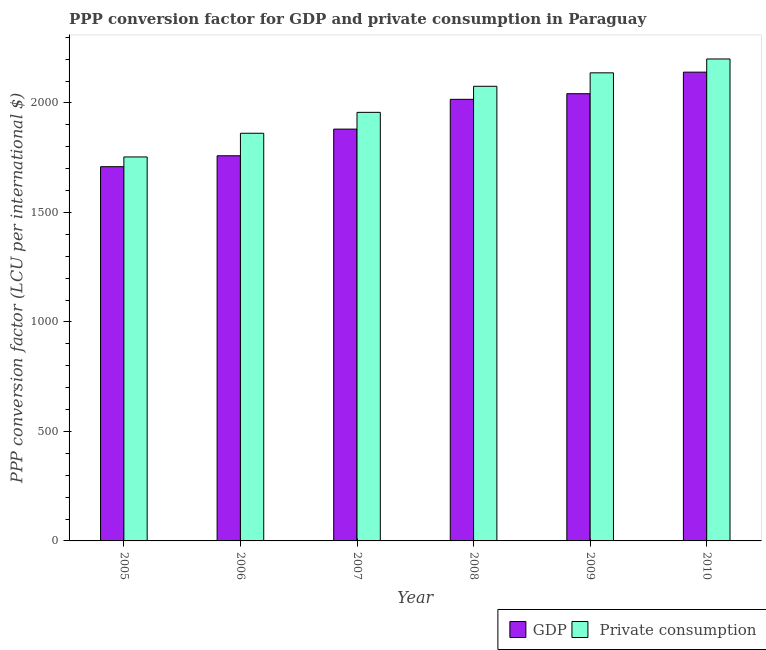Are the number of bars on each tick of the X-axis equal?
Offer a very short reply. Yes. How many bars are there on the 4th tick from the left?
Provide a short and direct response. 2. How many bars are there on the 5th tick from the right?
Your answer should be compact. 2. What is the ppp conversion factor for private consumption in 2007?
Offer a terse response. 1956.94. Across all years, what is the maximum ppp conversion factor for private consumption?
Give a very brief answer. 2200.69. Across all years, what is the minimum ppp conversion factor for private consumption?
Give a very brief answer. 1753.34. What is the total ppp conversion factor for private consumption in the graph?
Make the answer very short. 1.20e+04. What is the difference between the ppp conversion factor for gdp in 2007 and that in 2008?
Provide a succinct answer. -135.99. What is the difference between the ppp conversion factor for gdp in 2008 and the ppp conversion factor for private consumption in 2007?
Your answer should be compact. 135.99. What is the average ppp conversion factor for gdp per year?
Your answer should be compact. 1924.47. In the year 2008, what is the difference between the ppp conversion factor for gdp and ppp conversion factor for private consumption?
Keep it short and to the point. 0. In how many years, is the ppp conversion factor for private consumption greater than 100 LCU?
Provide a succinct answer. 6. What is the ratio of the ppp conversion factor for gdp in 2007 to that in 2009?
Ensure brevity in your answer.  0.92. Is the ppp conversion factor for gdp in 2008 less than that in 2009?
Your answer should be very brief. Yes. What is the difference between the highest and the second highest ppp conversion factor for gdp?
Keep it short and to the point. 98.43. What is the difference between the highest and the lowest ppp conversion factor for private consumption?
Keep it short and to the point. 447.35. Is the sum of the ppp conversion factor for gdp in 2005 and 2008 greater than the maximum ppp conversion factor for private consumption across all years?
Offer a terse response. Yes. What does the 2nd bar from the left in 2010 represents?
Give a very brief answer.  Private consumption. What does the 2nd bar from the right in 2006 represents?
Give a very brief answer. GDP. How many bars are there?
Provide a succinct answer. 12. Are all the bars in the graph horizontal?
Your answer should be very brief. No. Does the graph contain any zero values?
Make the answer very short. No. What is the title of the graph?
Keep it short and to the point. PPP conversion factor for GDP and private consumption in Paraguay. What is the label or title of the Y-axis?
Offer a very short reply. PPP conversion factor (LCU per international $). What is the PPP conversion factor (LCU per international $) of GDP in 2005?
Make the answer very short. 1708.78. What is the PPP conversion factor (LCU per international $) in  Private consumption in 2005?
Give a very brief answer. 1753.34. What is the PPP conversion factor (LCU per international $) of GDP in 2006?
Give a very brief answer. 1758.68. What is the PPP conversion factor (LCU per international $) in  Private consumption in 2006?
Provide a short and direct response. 1861.45. What is the PPP conversion factor (LCU per international $) of GDP in 2007?
Provide a succinct answer. 1880.39. What is the PPP conversion factor (LCU per international $) of  Private consumption in 2007?
Ensure brevity in your answer.  1956.94. What is the PPP conversion factor (LCU per international $) in GDP in 2008?
Ensure brevity in your answer.  2016.39. What is the PPP conversion factor (LCU per international $) in  Private consumption in 2008?
Make the answer very short. 2075.96. What is the PPP conversion factor (LCU per international $) in GDP in 2009?
Provide a short and direct response. 2042.08. What is the PPP conversion factor (LCU per international $) in  Private consumption in 2009?
Provide a short and direct response. 2137.37. What is the PPP conversion factor (LCU per international $) of GDP in 2010?
Provide a short and direct response. 2140.51. What is the PPP conversion factor (LCU per international $) in  Private consumption in 2010?
Ensure brevity in your answer.  2200.69. Across all years, what is the maximum PPP conversion factor (LCU per international $) of GDP?
Provide a short and direct response. 2140.51. Across all years, what is the maximum PPP conversion factor (LCU per international $) of  Private consumption?
Make the answer very short. 2200.69. Across all years, what is the minimum PPP conversion factor (LCU per international $) in GDP?
Give a very brief answer. 1708.78. Across all years, what is the minimum PPP conversion factor (LCU per international $) of  Private consumption?
Your response must be concise. 1753.34. What is the total PPP conversion factor (LCU per international $) of GDP in the graph?
Offer a very short reply. 1.15e+04. What is the total PPP conversion factor (LCU per international $) of  Private consumption in the graph?
Give a very brief answer. 1.20e+04. What is the difference between the PPP conversion factor (LCU per international $) of GDP in 2005 and that in 2006?
Offer a terse response. -49.91. What is the difference between the PPP conversion factor (LCU per international $) in  Private consumption in 2005 and that in 2006?
Offer a terse response. -108.12. What is the difference between the PPP conversion factor (LCU per international $) in GDP in 2005 and that in 2007?
Offer a terse response. -171.62. What is the difference between the PPP conversion factor (LCU per international $) of  Private consumption in 2005 and that in 2007?
Your answer should be compact. -203.61. What is the difference between the PPP conversion factor (LCU per international $) of GDP in 2005 and that in 2008?
Make the answer very short. -307.61. What is the difference between the PPP conversion factor (LCU per international $) in  Private consumption in 2005 and that in 2008?
Ensure brevity in your answer.  -322.63. What is the difference between the PPP conversion factor (LCU per international $) in GDP in 2005 and that in 2009?
Your answer should be very brief. -333.3. What is the difference between the PPP conversion factor (LCU per international $) in  Private consumption in 2005 and that in 2009?
Provide a short and direct response. -384.03. What is the difference between the PPP conversion factor (LCU per international $) in GDP in 2005 and that in 2010?
Give a very brief answer. -431.73. What is the difference between the PPP conversion factor (LCU per international $) of  Private consumption in 2005 and that in 2010?
Offer a terse response. -447.35. What is the difference between the PPP conversion factor (LCU per international $) of GDP in 2006 and that in 2007?
Offer a terse response. -121.71. What is the difference between the PPP conversion factor (LCU per international $) of  Private consumption in 2006 and that in 2007?
Provide a short and direct response. -95.49. What is the difference between the PPP conversion factor (LCU per international $) of GDP in 2006 and that in 2008?
Give a very brief answer. -257.7. What is the difference between the PPP conversion factor (LCU per international $) of  Private consumption in 2006 and that in 2008?
Make the answer very short. -214.51. What is the difference between the PPP conversion factor (LCU per international $) of GDP in 2006 and that in 2009?
Give a very brief answer. -283.39. What is the difference between the PPP conversion factor (LCU per international $) in  Private consumption in 2006 and that in 2009?
Keep it short and to the point. -275.92. What is the difference between the PPP conversion factor (LCU per international $) in GDP in 2006 and that in 2010?
Provide a succinct answer. -381.82. What is the difference between the PPP conversion factor (LCU per international $) of  Private consumption in 2006 and that in 2010?
Your response must be concise. -339.24. What is the difference between the PPP conversion factor (LCU per international $) in GDP in 2007 and that in 2008?
Your answer should be very brief. -135.99. What is the difference between the PPP conversion factor (LCU per international $) in  Private consumption in 2007 and that in 2008?
Your response must be concise. -119.02. What is the difference between the PPP conversion factor (LCU per international $) of GDP in 2007 and that in 2009?
Give a very brief answer. -161.68. What is the difference between the PPP conversion factor (LCU per international $) in  Private consumption in 2007 and that in 2009?
Provide a succinct answer. -180.43. What is the difference between the PPP conversion factor (LCU per international $) of GDP in 2007 and that in 2010?
Give a very brief answer. -260.11. What is the difference between the PPP conversion factor (LCU per international $) in  Private consumption in 2007 and that in 2010?
Offer a very short reply. -243.75. What is the difference between the PPP conversion factor (LCU per international $) in GDP in 2008 and that in 2009?
Offer a very short reply. -25.69. What is the difference between the PPP conversion factor (LCU per international $) of  Private consumption in 2008 and that in 2009?
Provide a succinct answer. -61.41. What is the difference between the PPP conversion factor (LCU per international $) of GDP in 2008 and that in 2010?
Your answer should be very brief. -124.12. What is the difference between the PPP conversion factor (LCU per international $) of  Private consumption in 2008 and that in 2010?
Provide a short and direct response. -124.73. What is the difference between the PPP conversion factor (LCU per international $) of GDP in 2009 and that in 2010?
Keep it short and to the point. -98.43. What is the difference between the PPP conversion factor (LCU per international $) in  Private consumption in 2009 and that in 2010?
Give a very brief answer. -63.32. What is the difference between the PPP conversion factor (LCU per international $) of GDP in 2005 and the PPP conversion factor (LCU per international $) of  Private consumption in 2006?
Your response must be concise. -152.68. What is the difference between the PPP conversion factor (LCU per international $) in GDP in 2005 and the PPP conversion factor (LCU per international $) in  Private consumption in 2007?
Offer a terse response. -248.17. What is the difference between the PPP conversion factor (LCU per international $) in GDP in 2005 and the PPP conversion factor (LCU per international $) in  Private consumption in 2008?
Keep it short and to the point. -367.19. What is the difference between the PPP conversion factor (LCU per international $) of GDP in 2005 and the PPP conversion factor (LCU per international $) of  Private consumption in 2009?
Offer a very short reply. -428.6. What is the difference between the PPP conversion factor (LCU per international $) in GDP in 2005 and the PPP conversion factor (LCU per international $) in  Private consumption in 2010?
Your answer should be very brief. -491.92. What is the difference between the PPP conversion factor (LCU per international $) of GDP in 2006 and the PPP conversion factor (LCU per international $) of  Private consumption in 2007?
Ensure brevity in your answer.  -198.26. What is the difference between the PPP conversion factor (LCU per international $) in GDP in 2006 and the PPP conversion factor (LCU per international $) in  Private consumption in 2008?
Ensure brevity in your answer.  -317.28. What is the difference between the PPP conversion factor (LCU per international $) of GDP in 2006 and the PPP conversion factor (LCU per international $) of  Private consumption in 2009?
Your answer should be compact. -378.69. What is the difference between the PPP conversion factor (LCU per international $) of GDP in 2006 and the PPP conversion factor (LCU per international $) of  Private consumption in 2010?
Offer a very short reply. -442.01. What is the difference between the PPP conversion factor (LCU per international $) in GDP in 2007 and the PPP conversion factor (LCU per international $) in  Private consumption in 2008?
Make the answer very short. -195.57. What is the difference between the PPP conversion factor (LCU per international $) in GDP in 2007 and the PPP conversion factor (LCU per international $) in  Private consumption in 2009?
Make the answer very short. -256.98. What is the difference between the PPP conversion factor (LCU per international $) in GDP in 2007 and the PPP conversion factor (LCU per international $) in  Private consumption in 2010?
Your answer should be compact. -320.3. What is the difference between the PPP conversion factor (LCU per international $) of GDP in 2008 and the PPP conversion factor (LCU per international $) of  Private consumption in 2009?
Give a very brief answer. -120.98. What is the difference between the PPP conversion factor (LCU per international $) in GDP in 2008 and the PPP conversion factor (LCU per international $) in  Private consumption in 2010?
Your response must be concise. -184.3. What is the difference between the PPP conversion factor (LCU per international $) of GDP in 2009 and the PPP conversion factor (LCU per international $) of  Private consumption in 2010?
Provide a short and direct response. -158.61. What is the average PPP conversion factor (LCU per international $) of GDP per year?
Your answer should be compact. 1924.47. What is the average PPP conversion factor (LCU per international $) in  Private consumption per year?
Give a very brief answer. 1997.63. In the year 2005, what is the difference between the PPP conversion factor (LCU per international $) of GDP and PPP conversion factor (LCU per international $) of  Private consumption?
Ensure brevity in your answer.  -44.56. In the year 2006, what is the difference between the PPP conversion factor (LCU per international $) of GDP and PPP conversion factor (LCU per international $) of  Private consumption?
Provide a succinct answer. -102.77. In the year 2007, what is the difference between the PPP conversion factor (LCU per international $) of GDP and PPP conversion factor (LCU per international $) of  Private consumption?
Offer a very short reply. -76.55. In the year 2008, what is the difference between the PPP conversion factor (LCU per international $) of GDP and PPP conversion factor (LCU per international $) of  Private consumption?
Make the answer very short. -59.57. In the year 2009, what is the difference between the PPP conversion factor (LCU per international $) in GDP and PPP conversion factor (LCU per international $) in  Private consumption?
Your answer should be compact. -95.29. In the year 2010, what is the difference between the PPP conversion factor (LCU per international $) in GDP and PPP conversion factor (LCU per international $) in  Private consumption?
Ensure brevity in your answer.  -60.18. What is the ratio of the PPP conversion factor (LCU per international $) in GDP in 2005 to that in 2006?
Offer a terse response. 0.97. What is the ratio of the PPP conversion factor (LCU per international $) in  Private consumption in 2005 to that in 2006?
Your response must be concise. 0.94. What is the ratio of the PPP conversion factor (LCU per international $) of GDP in 2005 to that in 2007?
Provide a short and direct response. 0.91. What is the ratio of the PPP conversion factor (LCU per international $) in  Private consumption in 2005 to that in 2007?
Your response must be concise. 0.9. What is the ratio of the PPP conversion factor (LCU per international $) in GDP in 2005 to that in 2008?
Ensure brevity in your answer.  0.85. What is the ratio of the PPP conversion factor (LCU per international $) in  Private consumption in 2005 to that in 2008?
Your answer should be very brief. 0.84. What is the ratio of the PPP conversion factor (LCU per international $) of GDP in 2005 to that in 2009?
Give a very brief answer. 0.84. What is the ratio of the PPP conversion factor (LCU per international $) of  Private consumption in 2005 to that in 2009?
Provide a short and direct response. 0.82. What is the ratio of the PPP conversion factor (LCU per international $) in GDP in 2005 to that in 2010?
Your answer should be compact. 0.8. What is the ratio of the PPP conversion factor (LCU per international $) in  Private consumption in 2005 to that in 2010?
Keep it short and to the point. 0.8. What is the ratio of the PPP conversion factor (LCU per international $) of GDP in 2006 to that in 2007?
Your answer should be compact. 0.94. What is the ratio of the PPP conversion factor (LCU per international $) in  Private consumption in 2006 to that in 2007?
Make the answer very short. 0.95. What is the ratio of the PPP conversion factor (LCU per international $) of GDP in 2006 to that in 2008?
Ensure brevity in your answer.  0.87. What is the ratio of the PPP conversion factor (LCU per international $) in  Private consumption in 2006 to that in 2008?
Offer a terse response. 0.9. What is the ratio of the PPP conversion factor (LCU per international $) in GDP in 2006 to that in 2009?
Ensure brevity in your answer.  0.86. What is the ratio of the PPP conversion factor (LCU per international $) in  Private consumption in 2006 to that in 2009?
Provide a short and direct response. 0.87. What is the ratio of the PPP conversion factor (LCU per international $) of GDP in 2006 to that in 2010?
Your answer should be very brief. 0.82. What is the ratio of the PPP conversion factor (LCU per international $) in  Private consumption in 2006 to that in 2010?
Provide a succinct answer. 0.85. What is the ratio of the PPP conversion factor (LCU per international $) in GDP in 2007 to that in 2008?
Ensure brevity in your answer.  0.93. What is the ratio of the PPP conversion factor (LCU per international $) of  Private consumption in 2007 to that in 2008?
Provide a succinct answer. 0.94. What is the ratio of the PPP conversion factor (LCU per international $) of GDP in 2007 to that in 2009?
Keep it short and to the point. 0.92. What is the ratio of the PPP conversion factor (LCU per international $) in  Private consumption in 2007 to that in 2009?
Ensure brevity in your answer.  0.92. What is the ratio of the PPP conversion factor (LCU per international $) of GDP in 2007 to that in 2010?
Ensure brevity in your answer.  0.88. What is the ratio of the PPP conversion factor (LCU per international $) of  Private consumption in 2007 to that in 2010?
Keep it short and to the point. 0.89. What is the ratio of the PPP conversion factor (LCU per international $) in GDP in 2008 to that in 2009?
Offer a very short reply. 0.99. What is the ratio of the PPP conversion factor (LCU per international $) of  Private consumption in 2008 to that in 2009?
Your answer should be very brief. 0.97. What is the ratio of the PPP conversion factor (LCU per international $) of GDP in 2008 to that in 2010?
Your response must be concise. 0.94. What is the ratio of the PPP conversion factor (LCU per international $) in  Private consumption in 2008 to that in 2010?
Provide a succinct answer. 0.94. What is the ratio of the PPP conversion factor (LCU per international $) of GDP in 2009 to that in 2010?
Give a very brief answer. 0.95. What is the ratio of the PPP conversion factor (LCU per international $) in  Private consumption in 2009 to that in 2010?
Keep it short and to the point. 0.97. What is the difference between the highest and the second highest PPP conversion factor (LCU per international $) of GDP?
Offer a very short reply. 98.43. What is the difference between the highest and the second highest PPP conversion factor (LCU per international $) of  Private consumption?
Offer a terse response. 63.32. What is the difference between the highest and the lowest PPP conversion factor (LCU per international $) of GDP?
Your answer should be very brief. 431.73. What is the difference between the highest and the lowest PPP conversion factor (LCU per international $) of  Private consumption?
Offer a terse response. 447.35. 